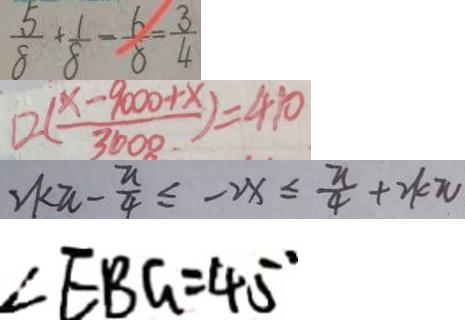<formula> <loc_0><loc_0><loc_500><loc_500>\frac { 5 } { 8 } + \frac { 1 } { 8 } - \frac { 6 } { 8 } = \frac { 3 } { 4 } 
 1 2 ( \frac { x - 9 0 0 0 + x } { 3 0 0 0 } ) = 4 1 0 
 2 k \pi - \frac { \pi } { 4 } \leq - 2 x \leq \frac { \pi } { 4 } + 2 k \pi 
 \angle E B G = 4 5 ^ { \circ }</formula> 